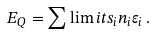<formula> <loc_0><loc_0><loc_500><loc_500>E _ { Q } = \sum \lim i t s _ { i } n _ { i } \varepsilon _ { i } \, .</formula> 